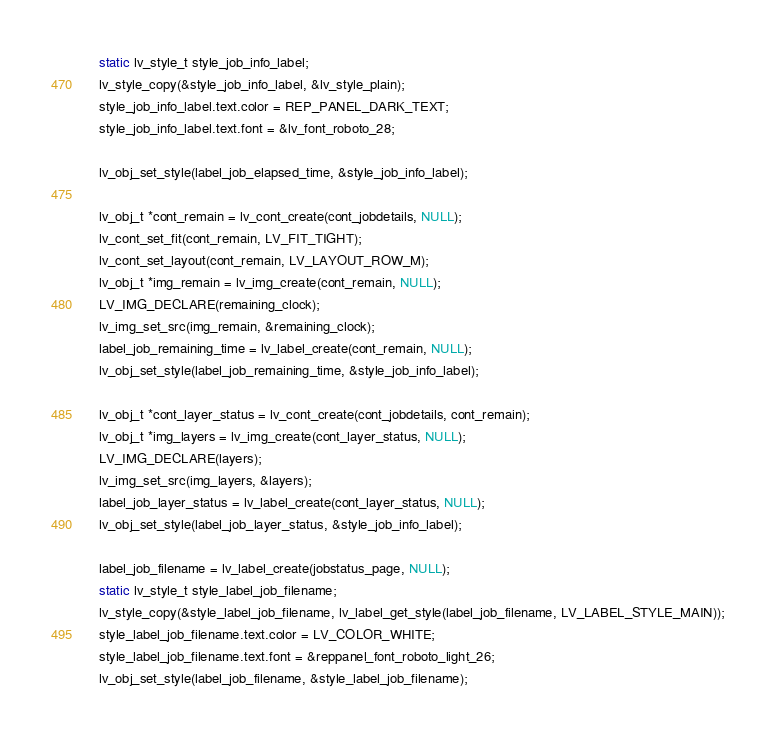<code> <loc_0><loc_0><loc_500><loc_500><_C_>    static lv_style_t style_job_info_label;
    lv_style_copy(&style_job_info_label, &lv_style_plain);
    style_job_info_label.text.color = REP_PANEL_DARK_TEXT;
    style_job_info_label.text.font = &lv_font_roboto_28;

    lv_obj_set_style(label_job_elapsed_time, &style_job_info_label);

    lv_obj_t *cont_remain = lv_cont_create(cont_jobdetails, NULL);
    lv_cont_set_fit(cont_remain, LV_FIT_TIGHT);
    lv_cont_set_layout(cont_remain, LV_LAYOUT_ROW_M);
    lv_obj_t *img_remain = lv_img_create(cont_remain, NULL);
    LV_IMG_DECLARE(remaining_clock);
    lv_img_set_src(img_remain, &remaining_clock);
    label_job_remaining_time = lv_label_create(cont_remain, NULL);
    lv_obj_set_style(label_job_remaining_time, &style_job_info_label);

    lv_obj_t *cont_layer_status = lv_cont_create(cont_jobdetails, cont_remain);
    lv_obj_t *img_layers = lv_img_create(cont_layer_status, NULL);
    LV_IMG_DECLARE(layers);
    lv_img_set_src(img_layers, &layers);
    label_job_layer_status = lv_label_create(cont_layer_status, NULL);
    lv_obj_set_style(label_job_layer_status, &style_job_info_label);

    label_job_filename = lv_label_create(jobstatus_page, NULL);
    static lv_style_t style_label_job_filename;
    lv_style_copy(&style_label_job_filename, lv_label_get_style(label_job_filename, LV_LABEL_STYLE_MAIN));
    style_label_job_filename.text.color = LV_COLOR_WHITE;
    style_label_job_filename.text.font = &reppanel_font_roboto_light_26;
    lv_obj_set_style(label_job_filename, &style_label_job_filename);</code> 